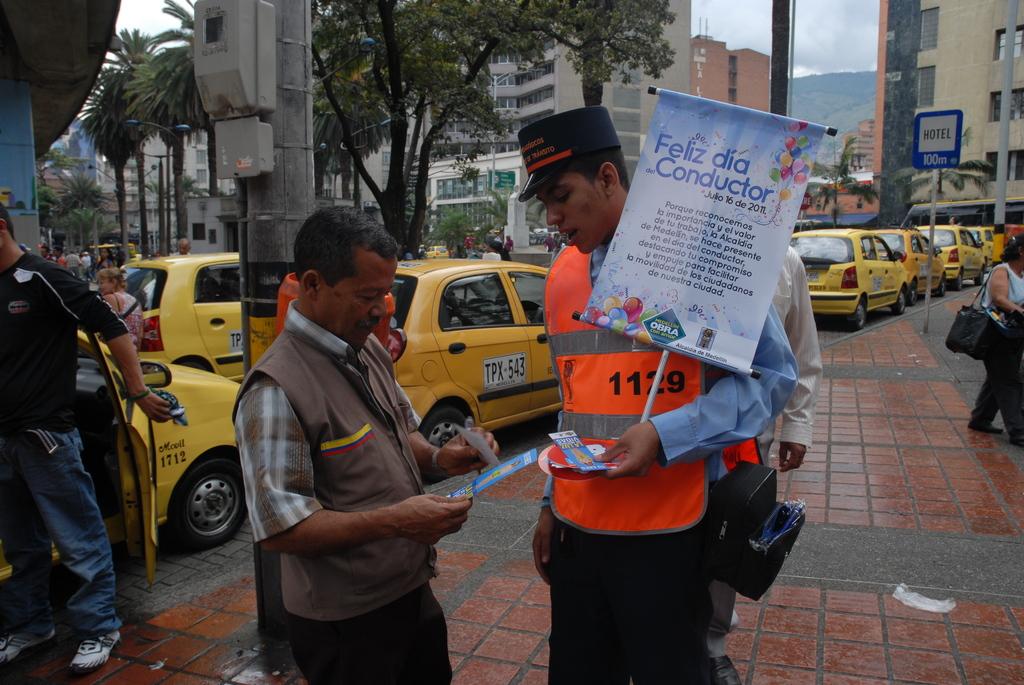What number is on the orange vest?
Keep it short and to the point. 1129. 